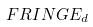<formula> <loc_0><loc_0><loc_500><loc_500>F R I N G E _ { d }</formula> 